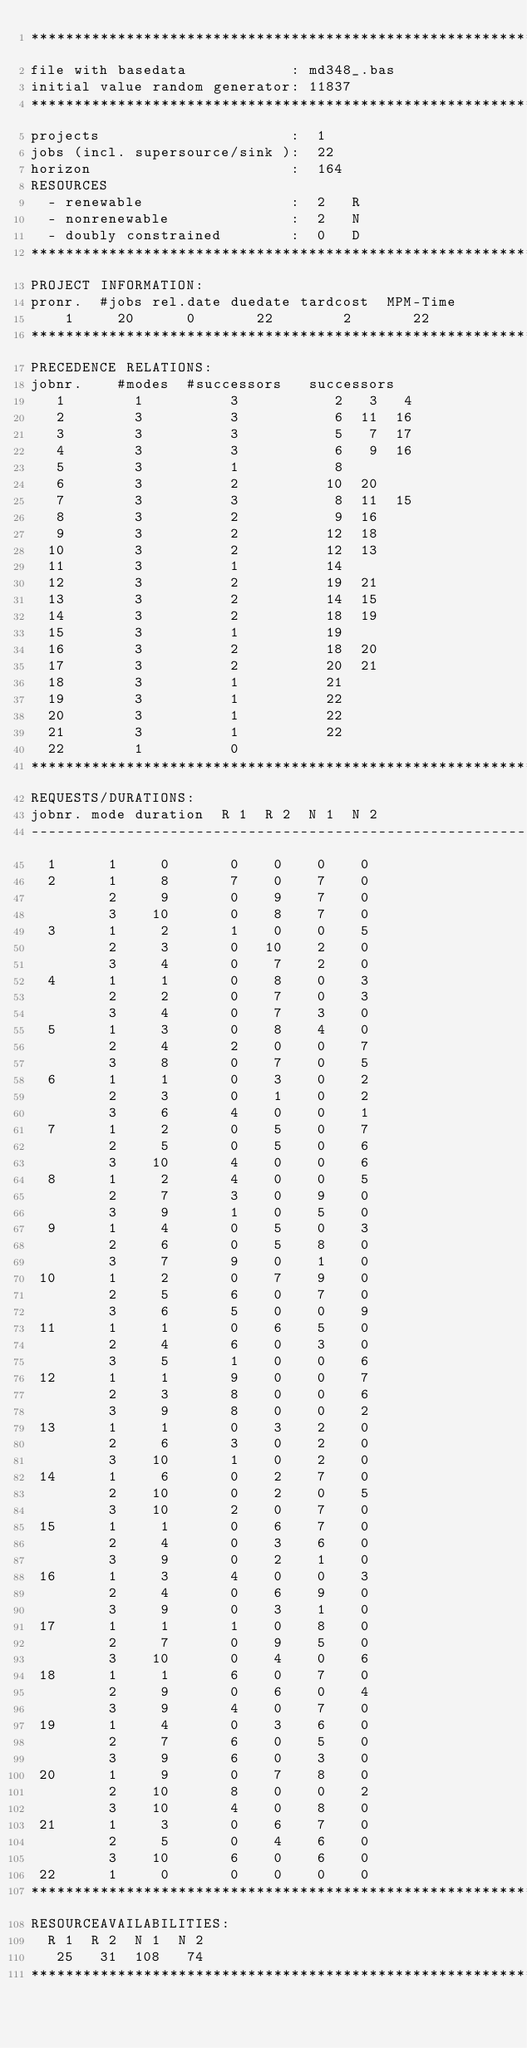<code> <loc_0><loc_0><loc_500><loc_500><_ObjectiveC_>************************************************************************
file with basedata            : md348_.bas
initial value random generator: 11837
************************************************************************
projects                      :  1
jobs (incl. supersource/sink ):  22
horizon                       :  164
RESOURCES
  - renewable                 :  2   R
  - nonrenewable              :  2   N
  - doubly constrained        :  0   D
************************************************************************
PROJECT INFORMATION:
pronr.  #jobs rel.date duedate tardcost  MPM-Time
    1     20      0       22        2       22
************************************************************************
PRECEDENCE RELATIONS:
jobnr.    #modes  #successors   successors
   1        1          3           2   3   4
   2        3          3           6  11  16
   3        3          3           5   7  17
   4        3          3           6   9  16
   5        3          1           8
   6        3          2          10  20
   7        3          3           8  11  15
   8        3          2           9  16
   9        3          2          12  18
  10        3          2          12  13
  11        3          1          14
  12        3          2          19  21
  13        3          2          14  15
  14        3          2          18  19
  15        3          1          19
  16        3          2          18  20
  17        3          2          20  21
  18        3          1          21
  19        3          1          22
  20        3          1          22
  21        3          1          22
  22        1          0        
************************************************************************
REQUESTS/DURATIONS:
jobnr. mode duration  R 1  R 2  N 1  N 2
------------------------------------------------------------------------
  1      1     0       0    0    0    0
  2      1     8       7    0    7    0
         2     9       0    9    7    0
         3    10       0    8    7    0
  3      1     2       1    0    0    5
         2     3       0   10    2    0
         3     4       0    7    2    0
  4      1     1       0    8    0    3
         2     2       0    7    0    3
         3     4       0    7    3    0
  5      1     3       0    8    4    0
         2     4       2    0    0    7
         3     8       0    7    0    5
  6      1     1       0    3    0    2
         2     3       0    1    0    2
         3     6       4    0    0    1
  7      1     2       0    5    0    7
         2     5       0    5    0    6
         3    10       4    0    0    6
  8      1     2       4    0    0    5
         2     7       3    0    9    0
         3     9       1    0    5    0
  9      1     4       0    5    0    3
         2     6       0    5    8    0
         3     7       9    0    1    0
 10      1     2       0    7    9    0
         2     5       6    0    7    0
         3     6       5    0    0    9
 11      1     1       0    6    5    0
         2     4       6    0    3    0
         3     5       1    0    0    6
 12      1     1       9    0    0    7
         2     3       8    0    0    6
         3     9       8    0    0    2
 13      1     1       0    3    2    0
         2     6       3    0    2    0
         3    10       1    0    2    0
 14      1     6       0    2    7    0
         2    10       0    2    0    5
         3    10       2    0    7    0
 15      1     1       0    6    7    0
         2     4       0    3    6    0
         3     9       0    2    1    0
 16      1     3       4    0    0    3
         2     4       0    6    9    0
         3     9       0    3    1    0
 17      1     1       1    0    8    0
         2     7       0    9    5    0
         3    10       0    4    0    6
 18      1     1       6    0    7    0
         2     9       0    6    0    4
         3     9       4    0    7    0
 19      1     4       0    3    6    0
         2     7       6    0    5    0
         3     9       6    0    3    0
 20      1     9       0    7    8    0
         2    10       8    0    0    2
         3    10       4    0    8    0
 21      1     3       0    6    7    0
         2     5       0    4    6    0
         3    10       6    0    6    0
 22      1     0       0    0    0    0
************************************************************************
RESOURCEAVAILABILITIES:
  R 1  R 2  N 1  N 2
   25   31  108   74
************************************************************************
</code> 